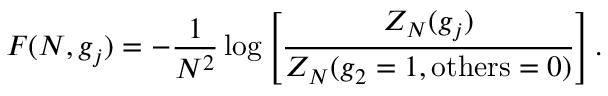<formula> <loc_0><loc_0><loc_500><loc_500>F ( N , g _ { j } ) = - \frac { 1 } { N ^ { 2 } } \log \left [ \frac { Z _ { N } ( g _ { j } ) } { Z _ { N } ( g _ { 2 } = 1 , o t h e r s = 0 ) } \right ] .</formula> 